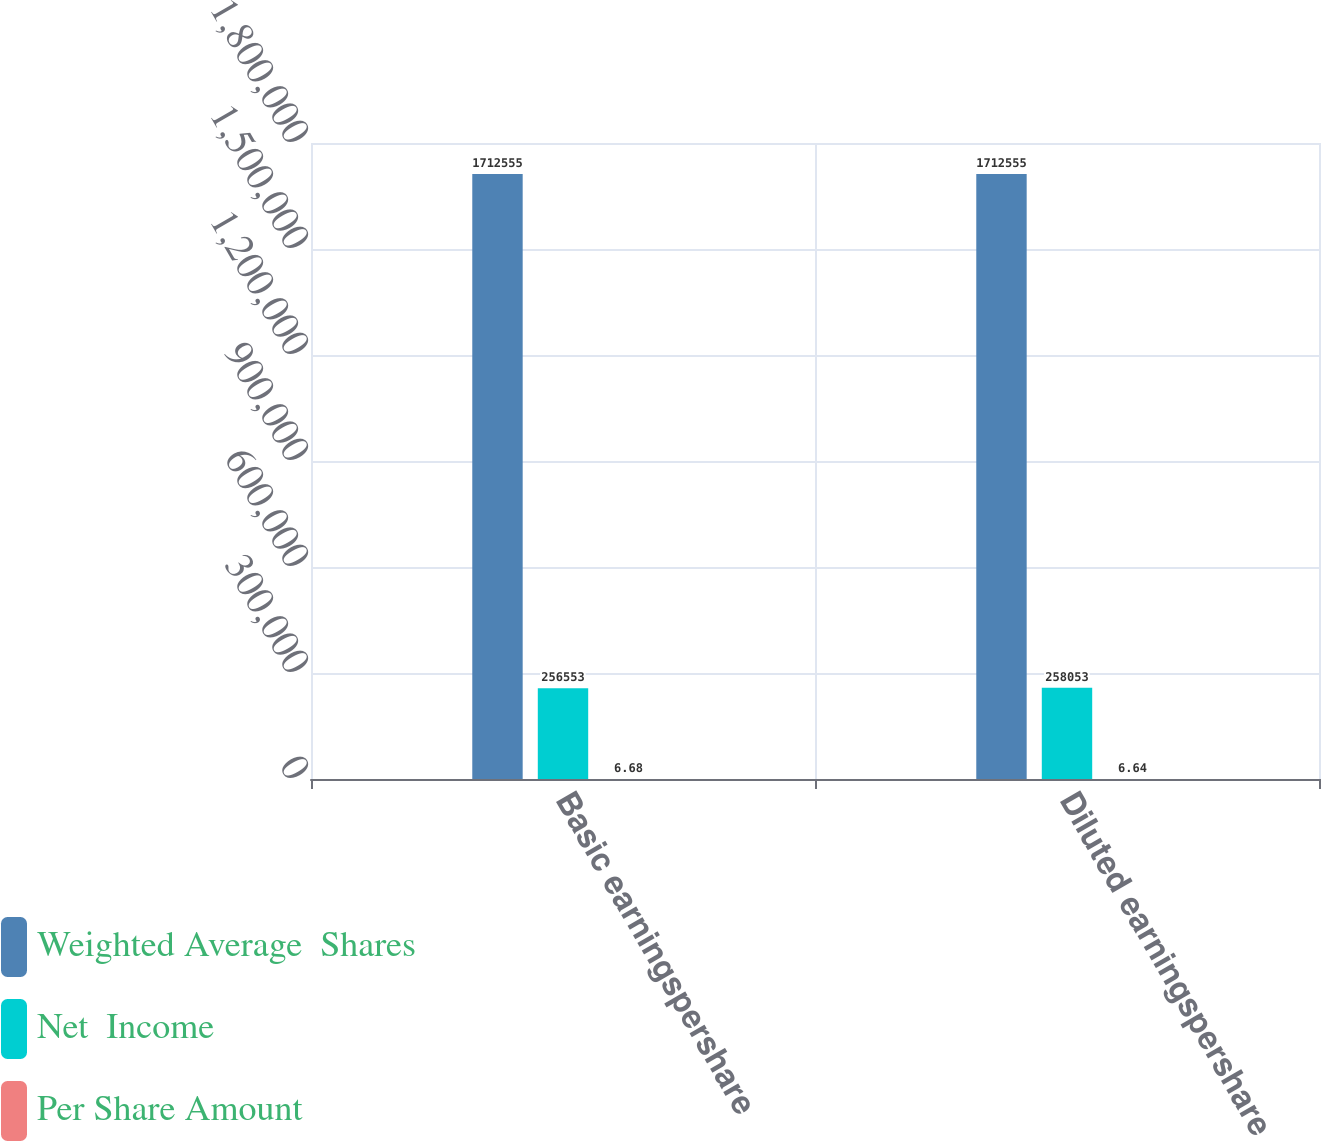<chart> <loc_0><loc_0><loc_500><loc_500><stacked_bar_chart><ecel><fcel>Basic earningspershare<fcel>Diluted earningspershare<nl><fcel>Weighted Average  Shares<fcel>1.71256e+06<fcel>1.71256e+06<nl><fcel>Net  Income<fcel>256553<fcel>258053<nl><fcel>Per Share Amount<fcel>6.68<fcel>6.64<nl></chart> 